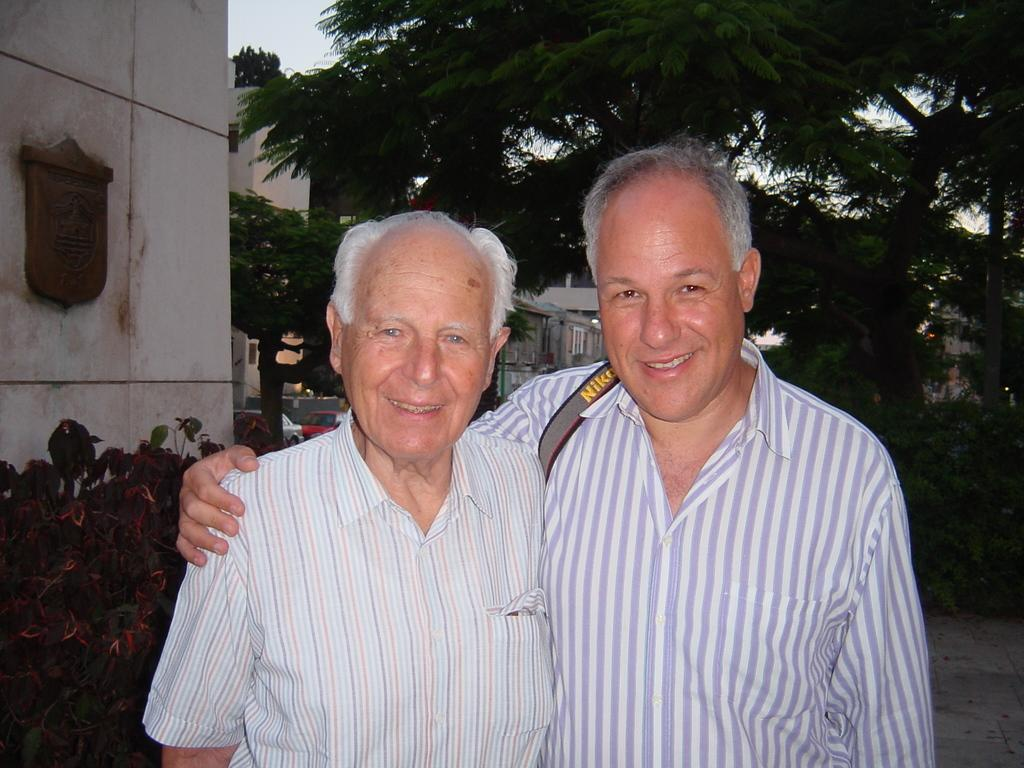<image>
Share a concise interpretation of the image provided. Two men posing for a picture one wearing a Nikon photo strap. 